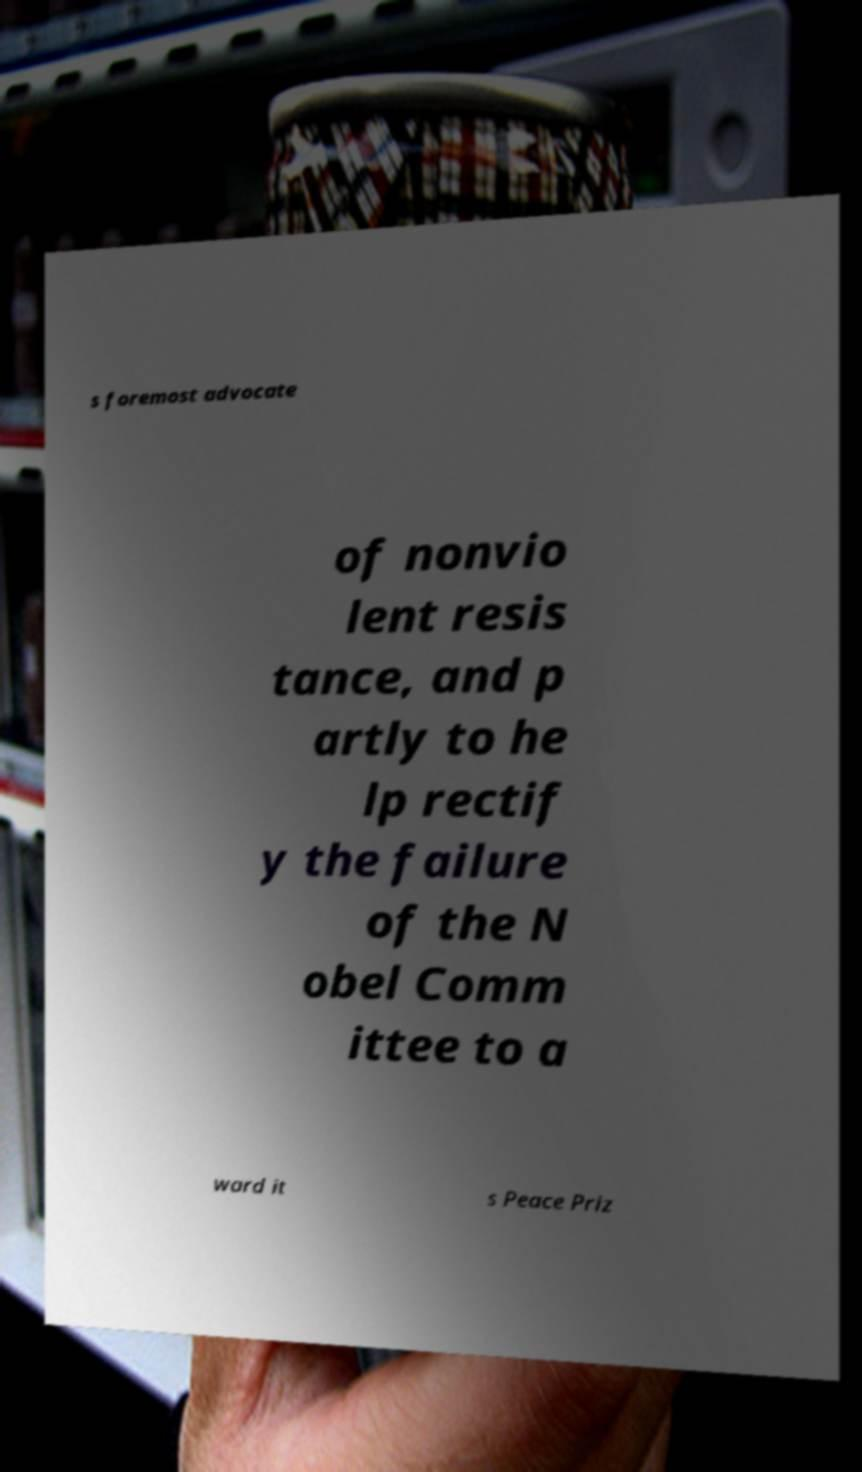Can you read and provide the text displayed in the image?This photo seems to have some interesting text. Can you extract and type it out for me? s foremost advocate of nonvio lent resis tance, and p artly to he lp rectif y the failure of the N obel Comm ittee to a ward it s Peace Priz 